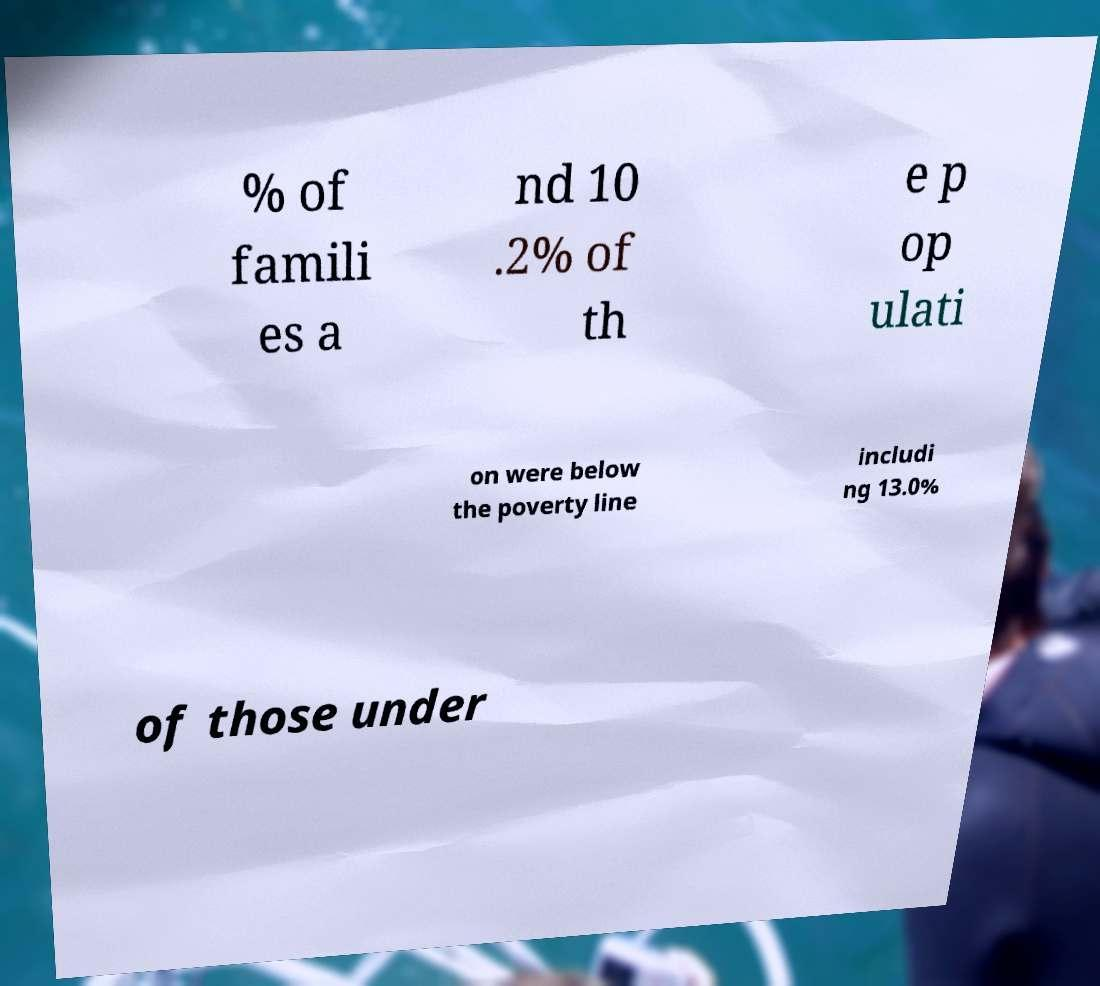Could you assist in decoding the text presented in this image and type it out clearly? % of famili es a nd 10 .2% of th e p op ulati on were below the poverty line includi ng 13.0% of those under 